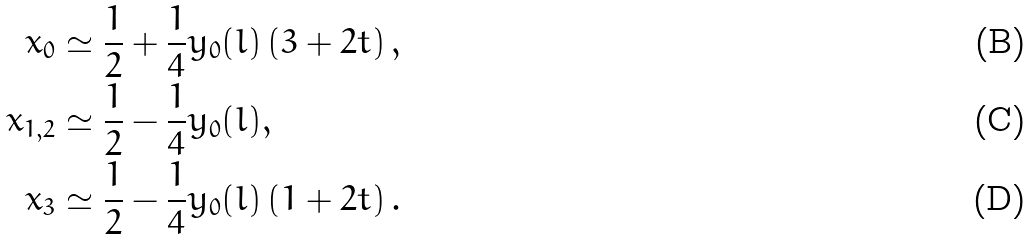Convert formula to latex. <formula><loc_0><loc_0><loc_500><loc_500>x _ { 0 } & \simeq \frac { 1 } { 2 } + \frac { 1 } { 4 } y _ { 0 } ( l ) \left ( 3 + 2 t \right ) , \\ x _ { 1 , 2 } & \simeq \frac { 1 } { 2 } - \frac { 1 } { 4 } y _ { 0 } ( l ) , \\ x _ { 3 } & \simeq \frac { 1 } { 2 } - \frac { 1 } { 4 } y _ { 0 } ( l ) \left ( 1 + 2 t \right ) .</formula> 